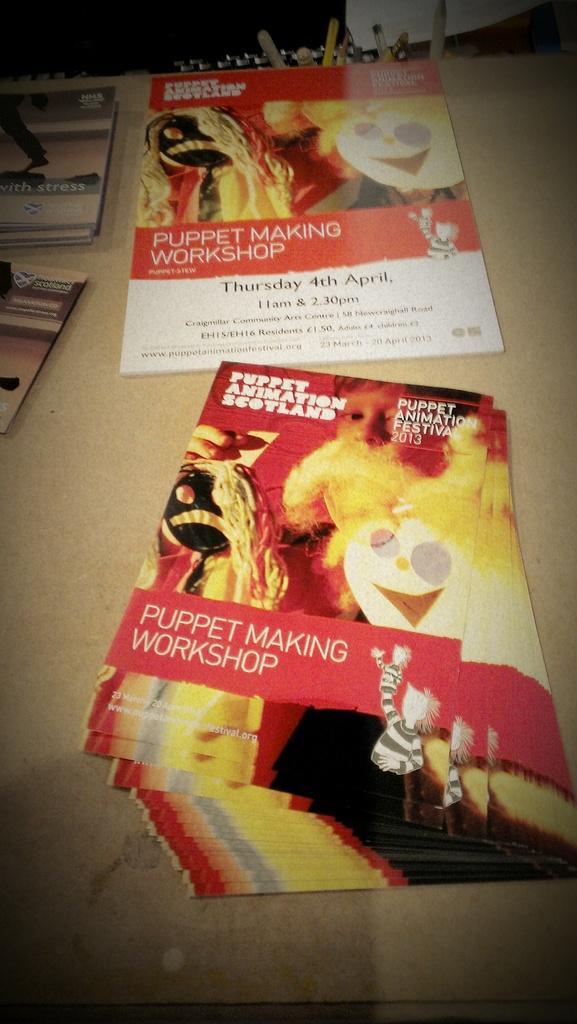How would you summarize this image in a sentence or two? Here I can see a table on which few pamphlets are placed. On the pamphlet, I can see some text and few cartoon images. 